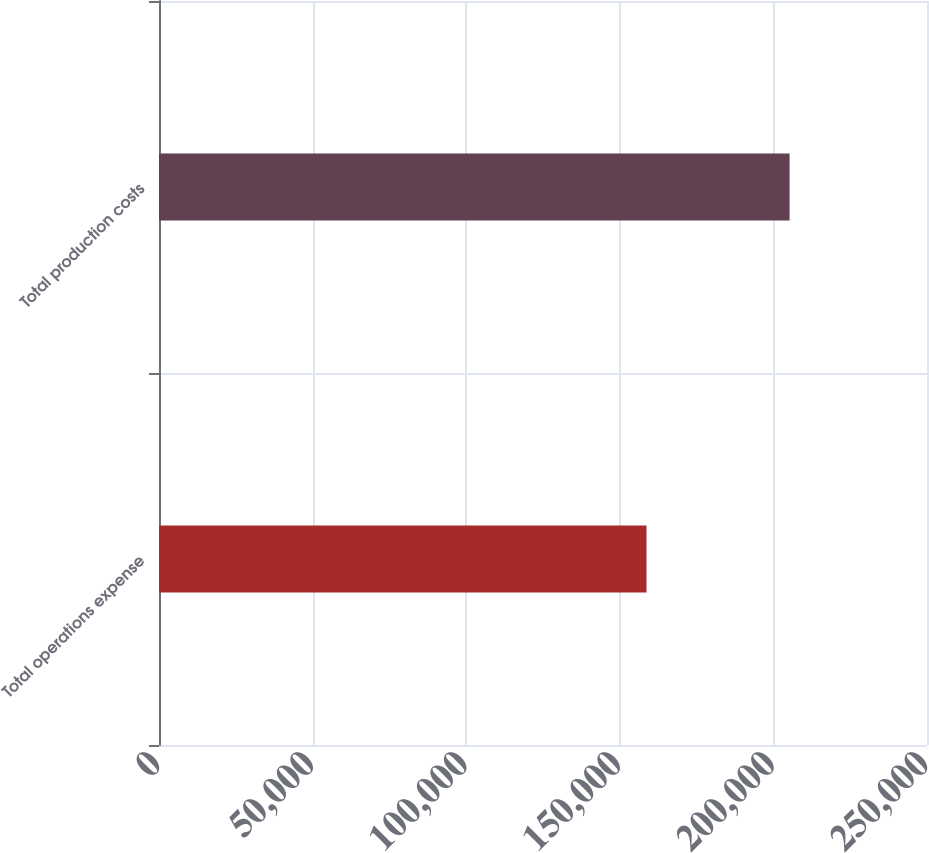<chart> <loc_0><loc_0><loc_500><loc_500><bar_chart><fcel>Total operations expense<fcel>Total production costs<nl><fcel>158695<fcel>205270<nl></chart> 